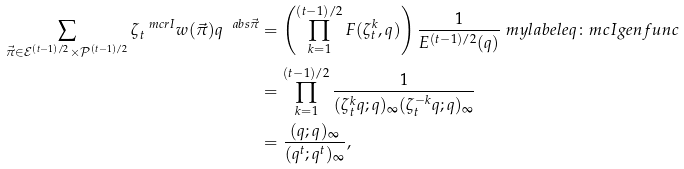<formula> <loc_0><loc_0><loc_500><loc_500>\sum _ { \vec { \pi } \in \mathcal { E } ^ { ( t - 1 ) / 2 } \times \mathcal { P } ^ { ( t - 1 ) / 2 } } \zeta _ { t } ^ { \ m c r I } w ( \vec { \pi } ) q ^ { \ a b s { \vec { \pi } } } & = \left ( \prod _ { k = 1 } ^ { ( t - 1 ) / 2 } F ( \zeta _ { t } ^ { k } , q ) \right ) \frac { 1 } { E ^ { ( t - 1 ) / 2 } ( q ) } \ m y l a b e l { e q \colon m c I g e n f u n c } \\ & = \prod _ { k = 1 } ^ { ( t - 1 ) / 2 } \frac { 1 } { ( \zeta _ { t } ^ { k } q ; q ) _ { \infty } ( \zeta _ { t } ^ { - k } q ; q ) _ { \infty } } \\ & = \frac { ( q ; q ) _ { \infty } } { ( q ^ { t } ; q ^ { t } ) _ { \infty } } ,</formula> 